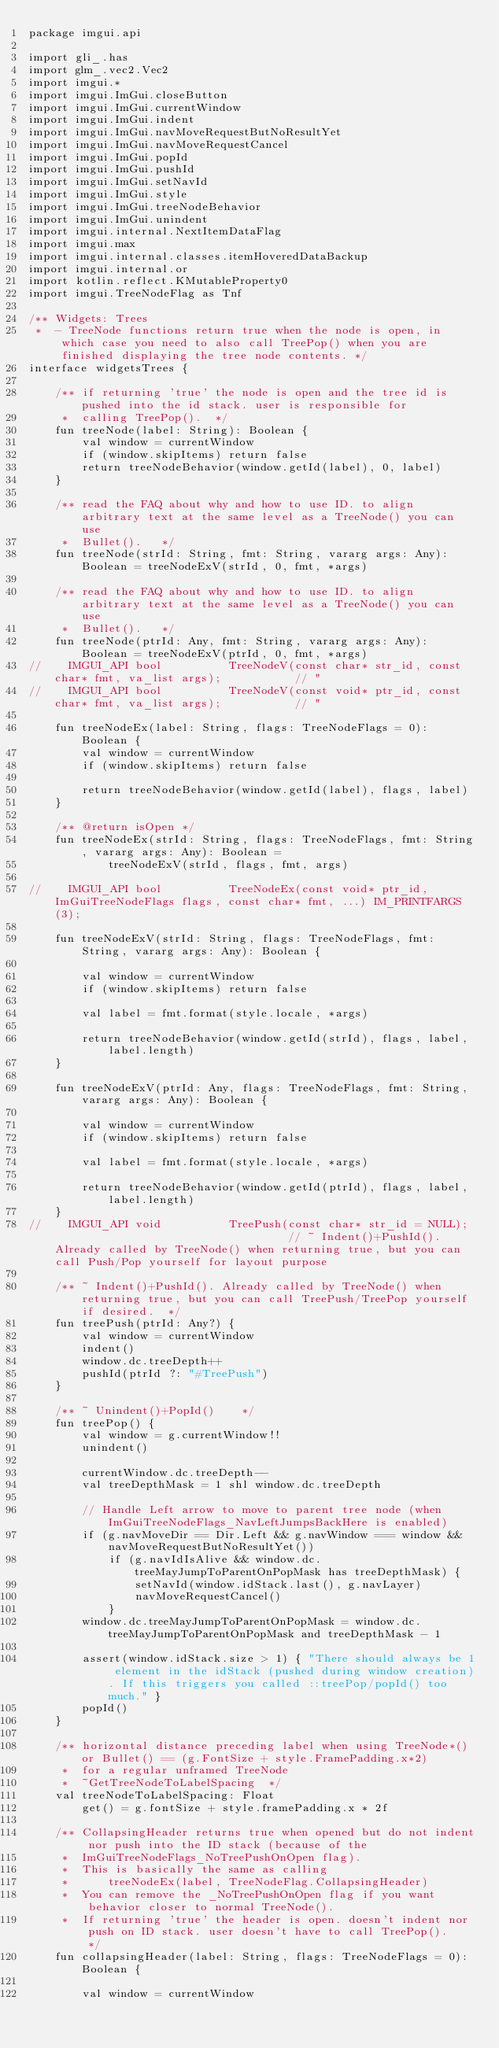<code> <loc_0><loc_0><loc_500><loc_500><_Kotlin_>package imgui.api

import gli_.has
import glm_.vec2.Vec2
import imgui.*
import imgui.ImGui.closeButton
import imgui.ImGui.currentWindow
import imgui.ImGui.indent
import imgui.ImGui.navMoveRequestButNoResultYet
import imgui.ImGui.navMoveRequestCancel
import imgui.ImGui.popId
import imgui.ImGui.pushId
import imgui.ImGui.setNavId
import imgui.ImGui.style
import imgui.ImGui.treeNodeBehavior
import imgui.ImGui.unindent
import imgui.internal.NextItemDataFlag
import imgui.max
import imgui.internal.classes.itemHoveredDataBackup
import imgui.internal.or
import kotlin.reflect.KMutableProperty0
import imgui.TreeNodeFlag as Tnf

/** Widgets: Trees
 *  - TreeNode functions return true when the node is open, in which case you need to also call TreePop() when you are finished displaying the tree node contents. */
interface widgetsTrees {

    /** if returning 'true' the node is open and the tree id is pushed into the id stack. user is responsible for
     *  calling TreePop().  */
    fun treeNode(label: String): Boolean {
        val window = currentWindow
        if (window.skipItems) return false
        return treeNodeBehavior(window.getId(label), 0, label)
    }

    /** read the FAQ about why and how to use ID. to align arbitrary text at the same level as a TreeNode() you can use
     *  Bullet().   */
    fun treeNode(strId: String, fmt: String, vararg args: Any): Boolean = treeNodeExV(strId, 0, fmt, *args)

    /** read the FAQ about why and how to use ID. to align arbitrary text at the same level as a TreeNode() you can use
     *  Bullet().   */
    fun treeNode(ptrId: Any, fmt: String, vararg args: Any): Boolean = treeNodeExV(ptrId, 0, fmt, *args)
//    IMGUI_API bool          TreeNodeV(const char* str_id, const char* fmt, va_list args);           // "
//    IMGUI_API bool          TreeNodeV(const void* ptr_id, const char* fmt, va_list args);           // "

    fun treeNodeEx(label: String, flags: TreeNodeFlags = 0): Boolean {
        val window = currentWindow
        if (window.skipItems) return false

        return treeNodeBehavior(window.getId(label), flags, label)
    }

    /** @return isOpen */
    fun treeNodeEx(strId: String, flags: TreeNodeFlags, fmt: String, vararg args: Any): Boolean =
            treeNodeExV(strId, flags, fmt, args)

//    IMGUI_API bool          TreeNodeEx(const void* ptr_id, ImGuiTreeNodeFlags flags, const char* fmt, ...) IM_PRINTFARGS(3);

    fun treeNodeExV(strId: String, flags: TreeNodeFlags, fmt: String, vararg args: Any): Boolean {

        val window = currentWindow
        if (window.skipItems) return false

        val label = fmt.format(style.locale, *args)

        return treeNodeBehavior(window.getId(strId), flags, label, label.length)
    }

    fun treeNodeExV(ptrId: Any, flags: TreeNodeFlags, fmt: String, vararg args: Any): Boolean {

        val window = currentWindow
        if (window.skipItems) return false

        val label = fmt.format(style.locale, *args)

        return treeNodeBehavior(window.getId(ptrId), flags, label, label.length)
    }
//    IMGUI_API void          TreePush(const char* str_id = NULL);                                    // ~ Indent()+PushId(). Already called by TreeNode() when returning true, but you can call Push/Pop yourself for layout purpose

    /** ~ Indent()+PushId(). Already called by TreeNode() when returning true, but you can call TreePush/TreePop yourself if desired.  */
    fun treePush(ptrId: Any?) {
        val window = currentWindow
        indent()
        window.dc.treeDepth++
        pushId(ptrId ?: "#TreePush")
    }

    /** ~ Unindent()+PopId()    */
    fun treePop() {
        val window = g.currentWindow!!
        unindent()

        currentWindow.dc.treeDepth--
        val treeDepthMask = 1 shl window.dc.treeDepth

        // Handle Left arrow to move to parent tree node (when ImGuiTreeNodeFlags_NavLeftJumpsBackHere is enabled)
        if (g.navMoveDir == Dir.Left && g.navWindow === window && navMoveRequestButNoResultYet())
            if (g.navIdIsAlive && window.dc.treeMayJumpToParentOnPopMask has treeDepthMask) {
                setNavId(window.idStack.last(), g.navLayer)
                navMoveRequestCancel()
            }
        window.dc.treeMayJumpToParentOnPopMask = window.dc.treeMayJumpToParentOnPopMask and treeDepthMask - 1

        assert(window.idStack.size > 1) { "There should always be 1 element in the idStack (pushed during window creation). If this triggers you called ::treePop/popId() too much." }
        popId()
    }

    /** horizontal distance preceding label when using TreeNode*() or Bullet() == (g.FontSize + style.FramePadding.x*2)
     *  for a regular unframed TreeNode
     *  ~GetTreeNodeToLabelSpacing  */
    val treeNodeToLabelSpacing: Float
        get() = g.fontSize + style.framePadding.x * 2f

    /** CollapsingHeader returns true when opened but do not indent nor push into the ID stack (because of the
     *  ImGuiTreeNodeFlags_NoTreePushOnOpen flag).
     *  This is basically the same as calling
     *      treeNodeEx(label, TreeNodeFlag.CollapsingHeader)
     *  You can remove the _NoTreePushOnOpen flag if you want behavior closer to normal TreeNode().
     *  If returning 'true' the header is open. doesn't indent nor push on ID stack. user doesn't have to call TreePop().   */
    fun collapsingHeader(label: String, flags: TreeNodeFlags = 0): Boolean {

        val window = currentWindow</code> 